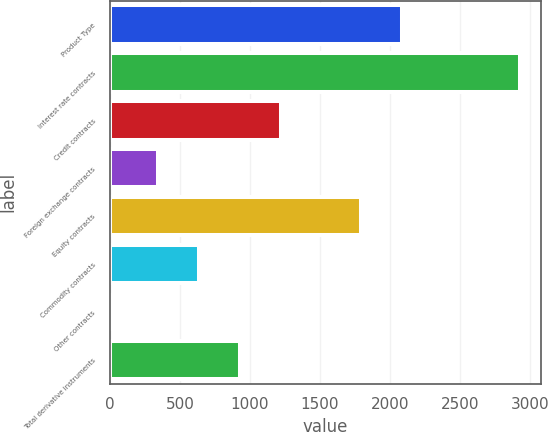Convert chart to OTSL. <chart><loc_0><loc_0><loc_500><loc_500><bar_chart><fcel>Product Type<fcel>Interest rate contracts<fcel>Credit contracts<fcel>Foreign exchange contracts<fcel>Equity contracts<fcel>Commodity contracts<fcel>Other contracts<fcel>Total derivative instruments<nl><fcel>2086.9<fcel>2930<fcel>1218.7<fcel>340<fcel>1794<fcel>632.9<fcel>1<fcel>925.8<nl></chart> 